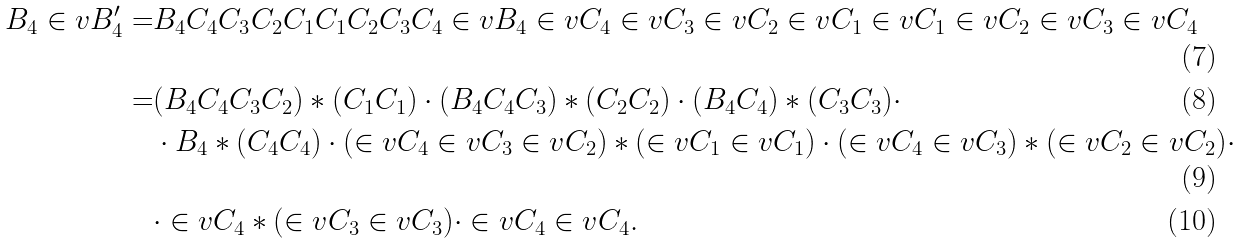Convert formula to latex. <formula><loc_0><loc_0><loc_500><loc_500>B _ { 4 } \in v { B _ { 4 } ^ { \prime } } = & B _ { 4 } C _ { 4 } C _ { 3 } C _ { 2 } C _ { 1 } C _ { 1 } C _ { 2 } C _ { 3 } C _ { 4 } \in v { B _ { 4 } } \in v { C _ { 4 } } \in v { C _ { 3 } } \in v { C _ { 2 } } \in v { C _ { 1 } } \in v { C _ { 1 } } \in v { C _ { 2 } } \in v { C _ { 3 } } \in v { C _ { 4 } } \\ = & ( B _ { 4 } C _ { 4 } C _ { 3 } C _ { 2 } ) * ( C _ { 1 } C _ { 1 } ) \cdot ( B _ { 4 } C _ { 4 } C _ { 3 } ) * ( C _ { 2 } C _ { 2 } ) \cdot ( B _ { 4 } C _ { 4 } ) * ( C _ { 3 } C _ { 3 } ) \cdot \\ & \cdot B _ { 4 } * ( C _ { 4 } C _ { 4 } ) \cdot ( \in v { C _ { 4 } } \in v { C _ { 3 } } \in v { C _ { 2 } } ) * ( \in v { C _ { 1 } } \in v { C _ { 1 } } ) \cdot ( \in v { C _ { 4 } } \in v { C _ { 3 } } ) * ( \in v { C _ { 2 } } \in v { C _ { 2 } } ) \cdot \\ & \cdot \in v { C _ { 4 } } * ( \in v { C _ { 3 } } \in v { C _ { 3 } } ) \cdot \in v { C _ { 4 } } \in v { C _ { 4 } } .</formula> 